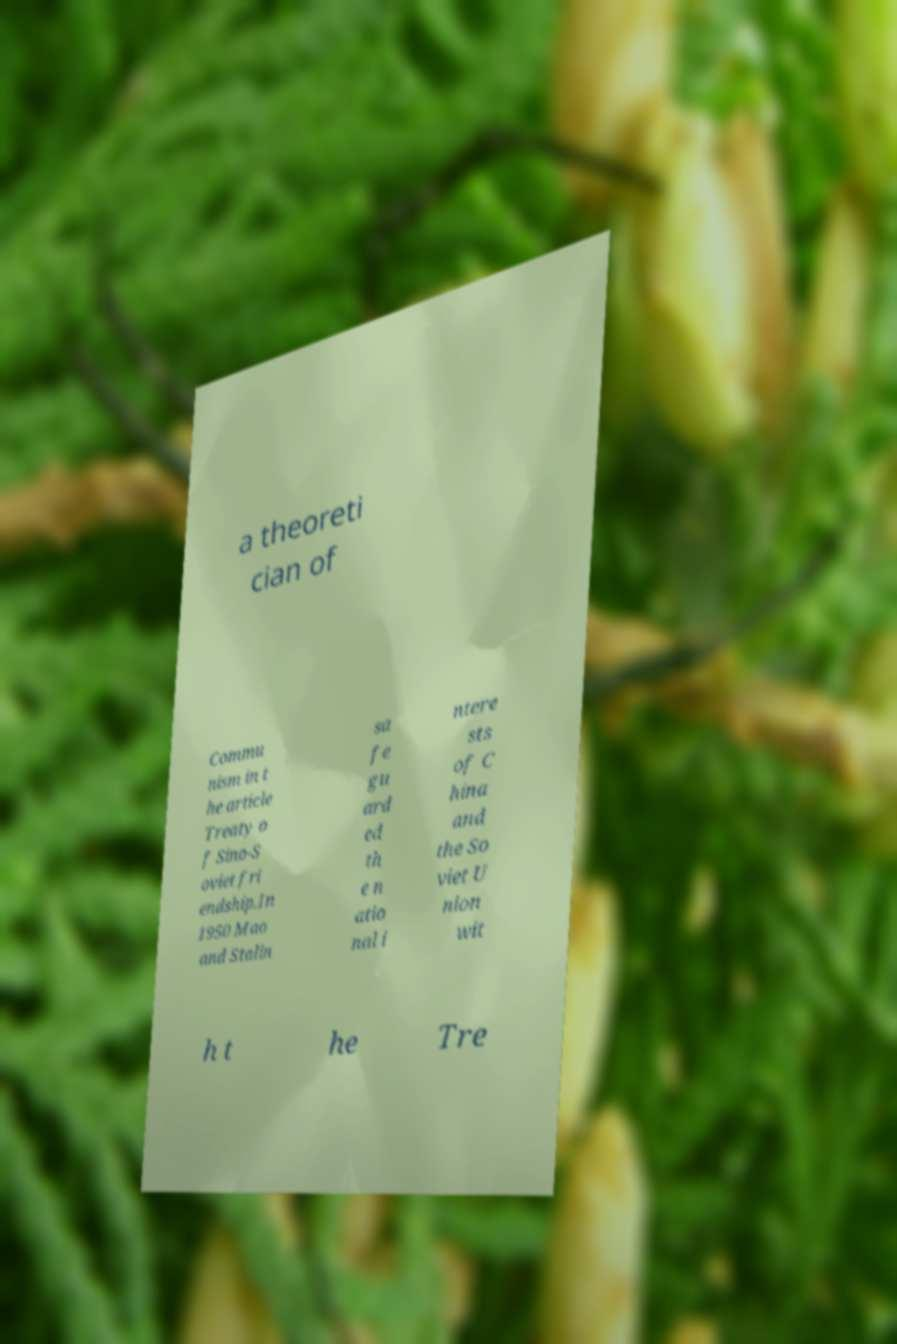What messages or text are displayed in this image? I need them in a readable, typed format. a theoreti cian of Commu nism in t he article Treaty o f Sino-S oviet fri endship.In 1950 Mao and Stalin sa fe gu ard ed th e n atio nal i ntere sts of C hina and the So viet U nion wit h t he Tre 